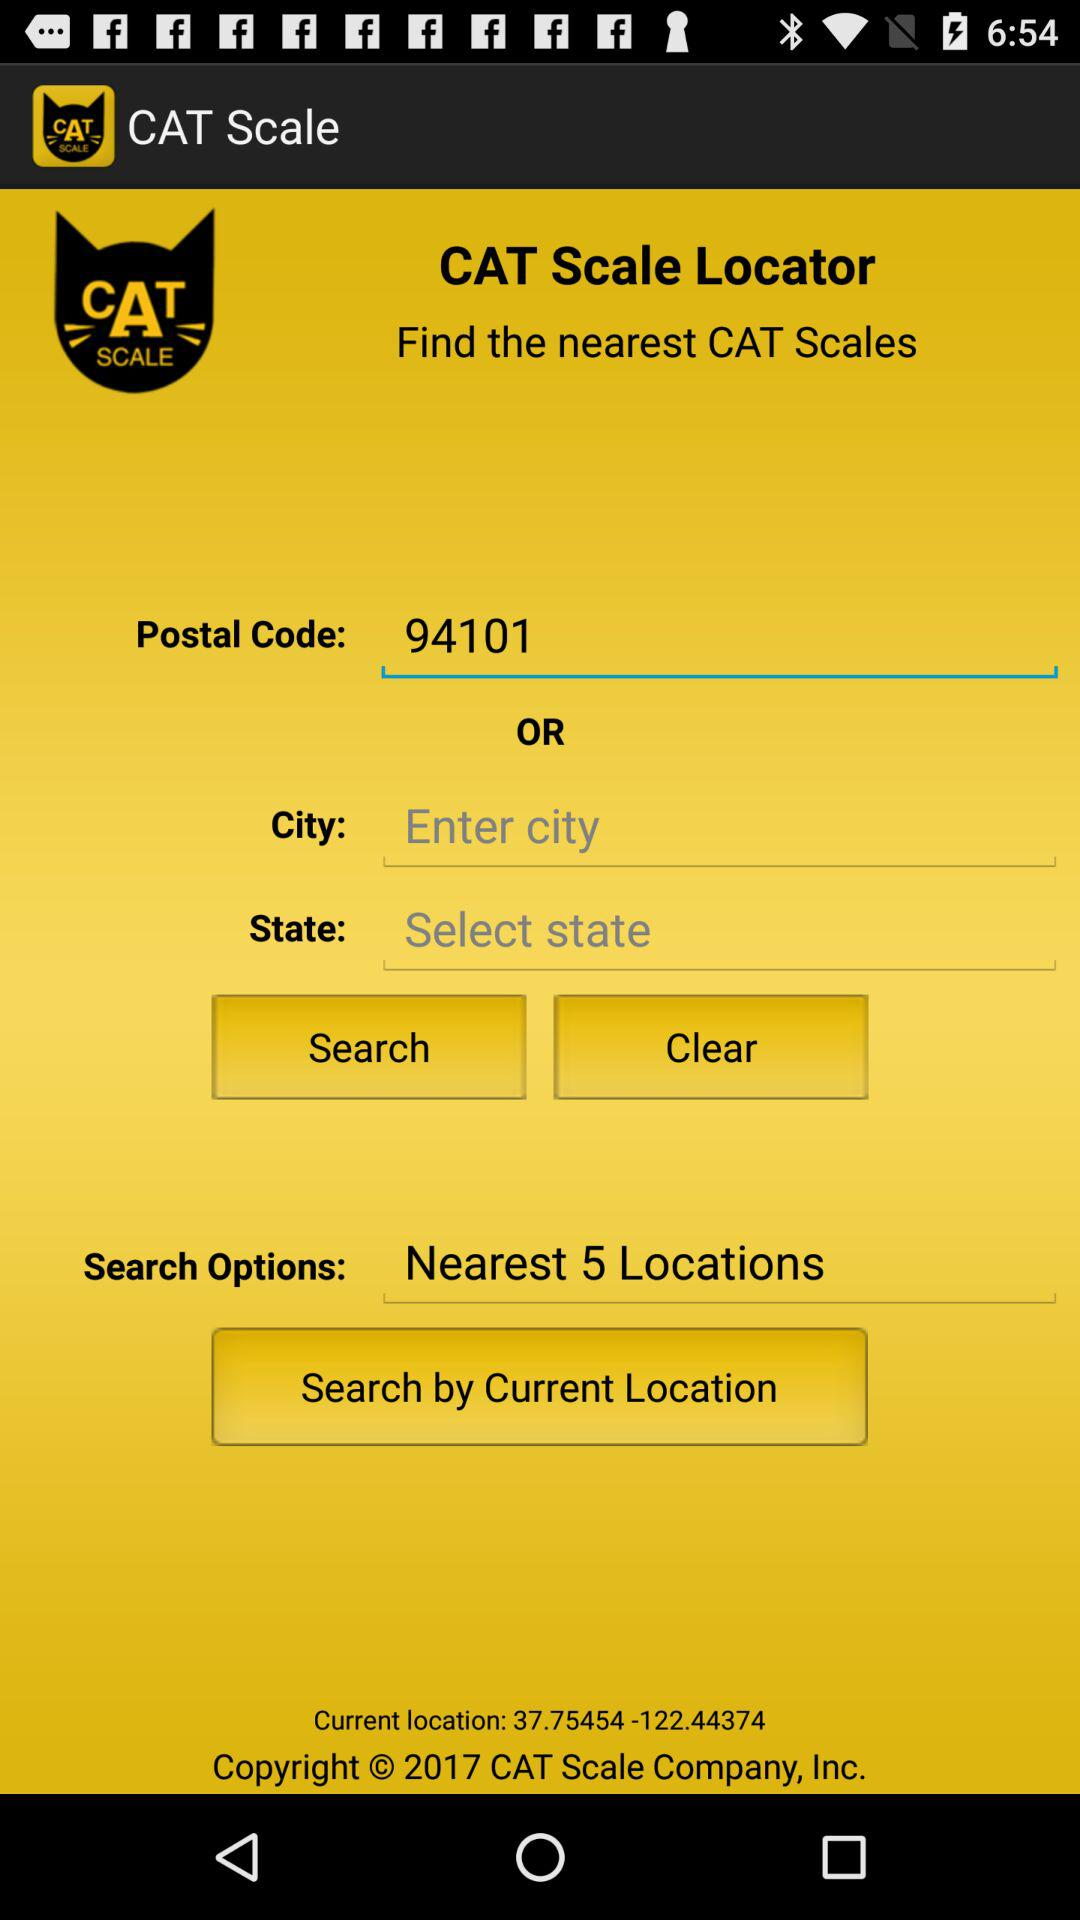How many nearest locations are there? There are 5 nearest locations. 